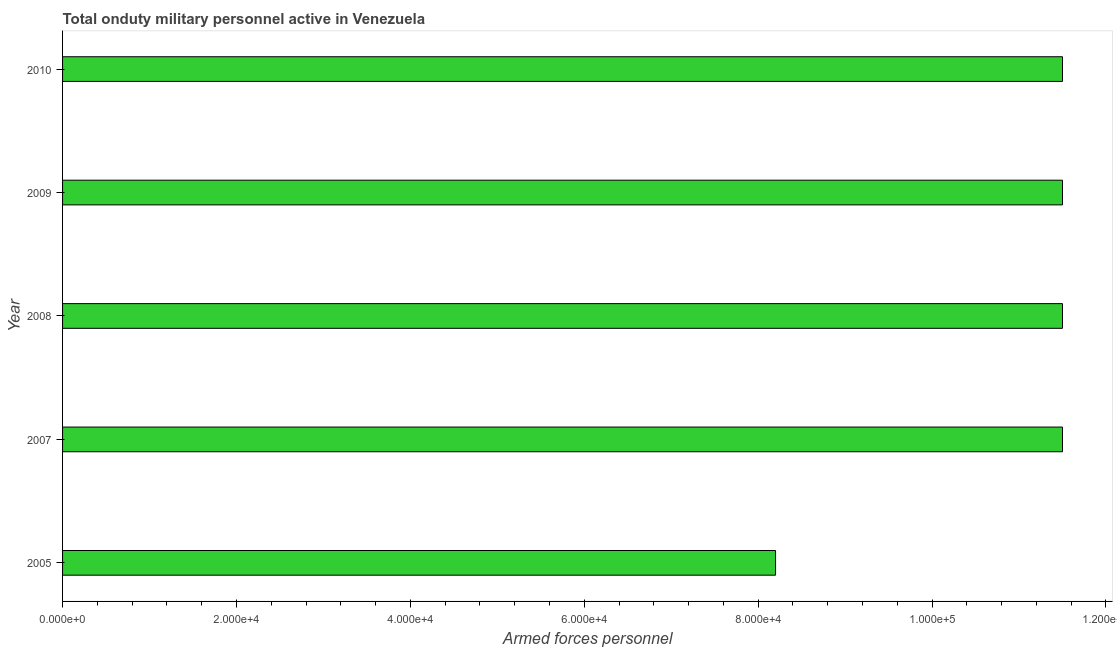Does the graph contain any zero values?
Offer a terse response. No. What is the title of the graph?
Ensure brevity in your answer.  Total onduty military personnel active in Venezuela. What is the label or title of the X-axis?
Offer a very short reply. Armed forces personnel. What is the label or title of the Y-axis?
Keep it short and to the point. Year. What is the number of armed forces personnel in 2005?
Provide a short and direct response. 8.20e+04. Across all years, what is the maximum number of armed forces personnel?
Offer a very short reply. 1.15e+05. Across all years, what is the minimum number of armed forces personnel?
Keep it short and to the point. 8.20e+04. What is the sum of the number of armed forces personnel?
Your answer should be very brief. 5.42e+05. What is the average number of armed forces personnel per year?
Your response must be concise. 1.08e+05. What is the median number of armed forces personnel?
Offer a very short reply. 1.15e+05. Do a majority of the years between 2008 and 2009 (inclusive) have number of armed forces personnel greater than 68000 ?
Offer a terse response. Yes. Is the number of armed forces personnel in 2005 less than that in 2007?
Make the answer very short. Yes. Is the difference between the number of armed forces personnel in 2005 and 2009 greater than the difference between any two years?
Offer a terse response. Yes. What is the difference between the highest and the second highest number of armed forces personnel?
Offer a terse response. 0. What is the difference between the highest and the lowest number of armed forces personnel?
Offer a very short reply. 3.30e+04. In how many years, is the number of armed forces personnel greater than the average number of armed forces personnel taken over all years?
Ensure brevity in your answer.  4. How many bars are there?
Keep it short and to the point. 5. What is the difference between two consecutive major ticks on the X-axis?
Your answer should be compact. 2.00e+04. Are the values on the major ticks of X-axis written in scientific E-notation?
Provide a short and direct response. Yes. What is the Armed forces personnel of 2005?
Make the answer very short. 8.20e+04. What is the Armed forces personnel of 2007?
Give a very brief answer. 1.15e+05. What is the Armed forces personnel of 2008?
Provide a short and direct response. 1.15e+05. What is the Armed forces personnel of 2009?
Your response must be concise. 1.15e+05. What is the Armed forces personnel in 2010?
Your response must be concise. 1.15e+05. What is the difference between the Armed forces personnel in 2005 and 2007?
Provide a succinct answer. -3.30e+04. What is the difference between the Armed forces personnel in 2005 and 2008?
Your response must be concise. -3.30e+04. What is the difference between the Armed forces personnel in 2005 and 2009?
Ensure brevity in your answer.  -3.30e+04. What is the difference between the Armed forces personnel in 2005 and 2010?
Keep it short and to the point. -3.30e+04. What is the difference between the Armed forces personnel in 2007 and 2008?
Provide a short and direct response. 0. What is the difference between the Armed forces personnel in 2007 and 2010?
Keep it short and to the point. 0. What is the difference between the Armed forces personnel in 2008 and 2009?
Make the answer very short. 0. What is the ratio of the Armed forces personnel in 2005 to that in 2007?
Your response must be concise. 0.71. What is the ratio of the Armed forces personnel in 2005 to that in 2008?
Provide a succinct answer. 0.71. What is the ratio of the Armed forces personnel in 2005 to that in 2009?
Your answer should be compact. 0.71. What is the ratio of the Armed forces personnel in 2005 to that in 2010?
Your answer should be compact. 0.71. What is the ratio of the Armed forces personnel in 2007 to that in 2009?
Your answer should be compact. 1. What is the ratio of the Armed forces personnel in 2007 to that in 2010?
Your response must be concise. 1. What is the ratio of the Armed forces personnel in 2009 to that in 2010?
Provide a short and direct response. 1. 